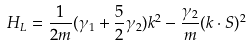<formula> <loc_0><loc_0><loc_500><loc_500>H _ { L } = \frac { 1 } { 2 m } ( \gamma _ { 1 } + \frac { 5 } { 2 } \gamma _ { 2 } ) k ^ { 2 } - \frac { \gamma _ { 2 } } { m } ( k \cdot S ) ^ { 2 }</formula> 